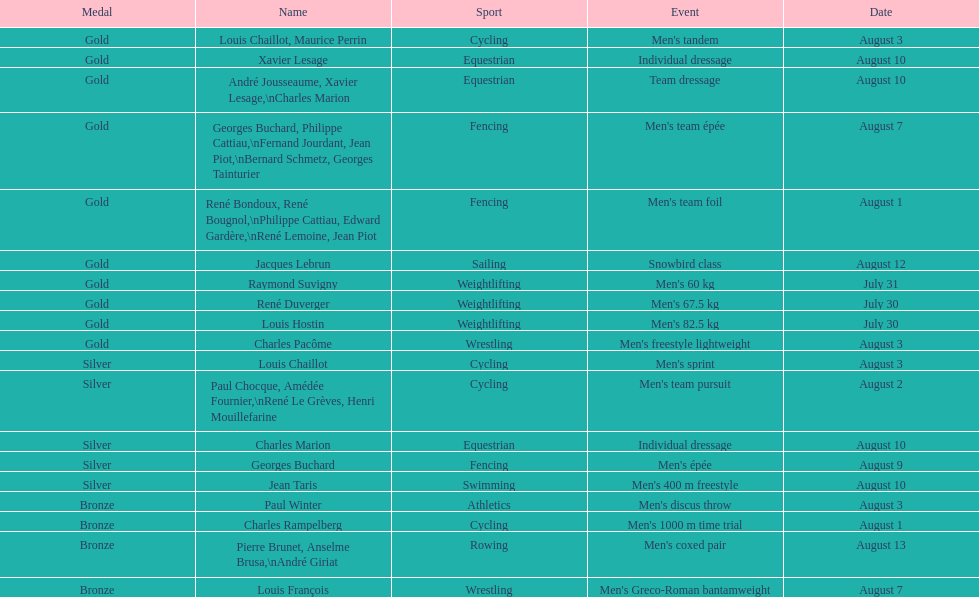How many total gold medals were won by weightlifting? 3. 